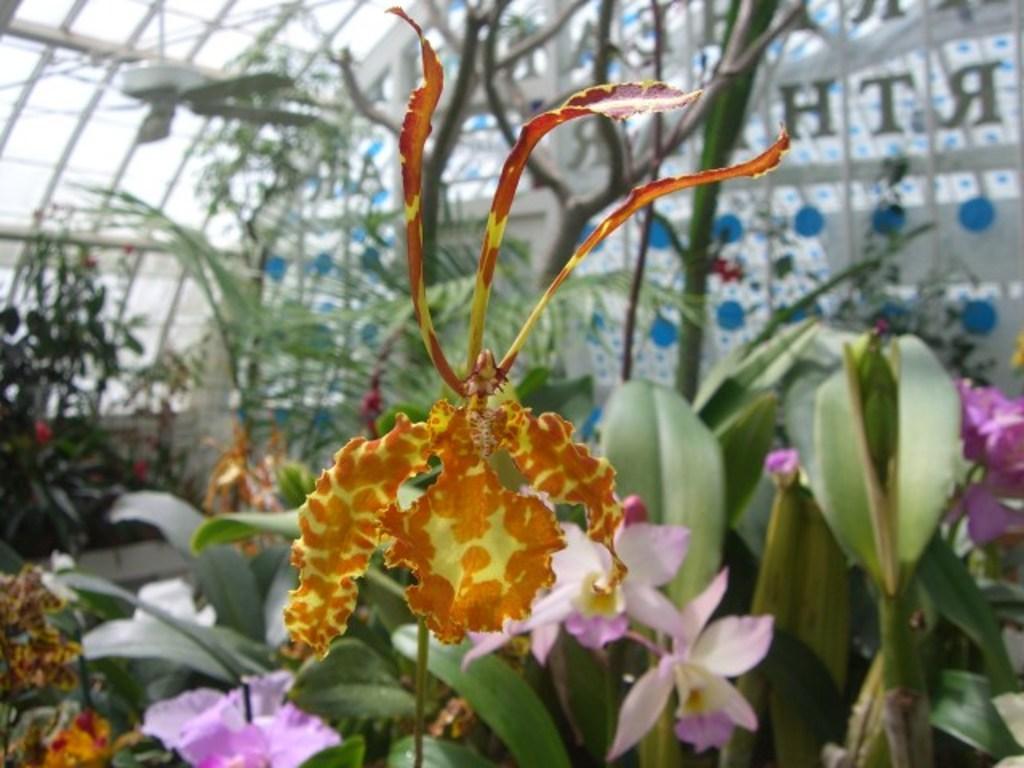Could you give a brief overview of what you see in this image? In this picture we can see plants, flowers, fan and in the background we can see glass with text on it. 